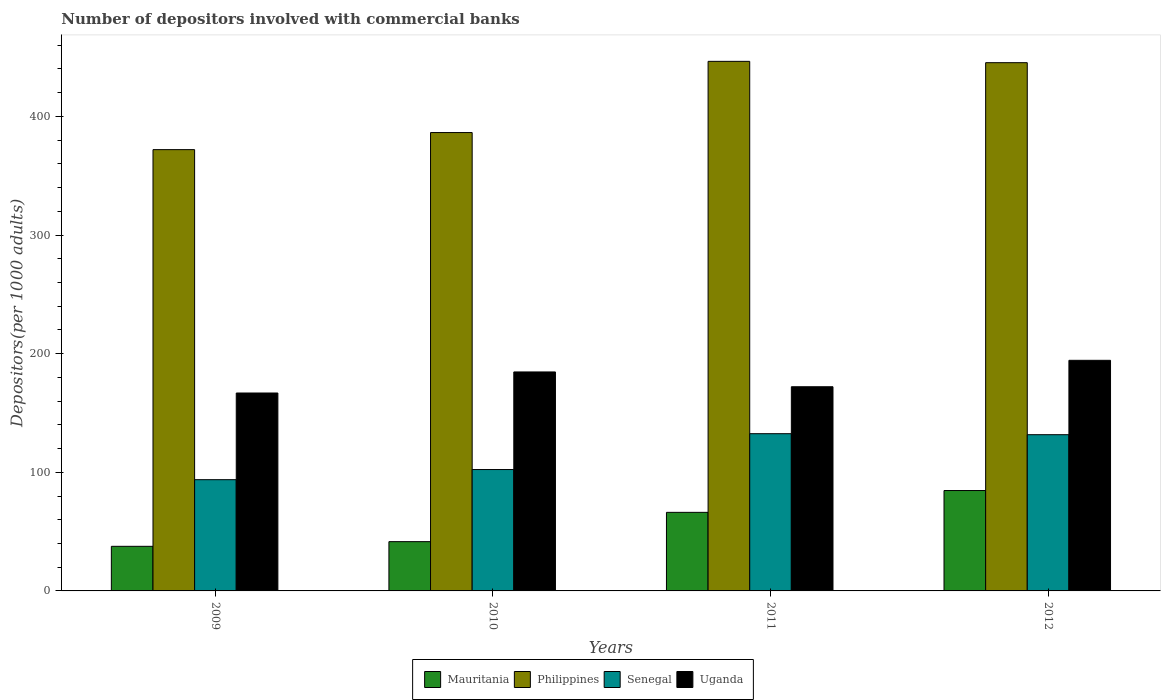How many different coloured bars are there?
Keep it short and to the point. 4. How many bars are there on the 3rd tick from the left?
Ensure brevity in your answer.  4. What is the number of depositors involved with commercial banks in Mauritania in 2009?
Your answer should be very brief. 37.6. Across all years, what is the maximum number of depositors involved with commercial banks in Philippines?
Keep it short and to the point. 446.4. Across all years, what is the minimum number of depositors involved with commercial banks in Philippines?
Give a very brief answer. 371.98. In which year was the number of depositors involved with commercial banks in Philippines minimum?
Provide a short and direct response. 2009. What is the total number of depositors involved with commercial banks in Mauritania in the graph?
Provide a succinct answer. 229.98. What is the difference between the number of depositors involved with commercial banks in Senegal in 2009 and that in 2012?
Ensure brevity in your answer.  -37.92. What is the difference between the number of depositors involved with commercial banks in Uganda in 2011 and the number of depositors involved with commercial banks in Mauritania in 2010?
Make the answer very short. 130.57. What is the average number of depositors involved with commercial banks in Mauritania per year?
Ensure brevity in your answer.  57.5. In the year 2010, what is the difference between the number of depositors involved with commercial banks in Uganda and number of depositors involved with commercial banks in Philippines?
Your answer should be compact. -201.8. In how many years, is the number of depositors involved with commercial banks in Philippines greater than 260?
Offer a very short reply. 4. What is the ratio of the number of depositors involved with commercial banks in Senegal in 2009 to that in 2011?
Offer a very short reply. 0.71. Is the difference between the number of depositors involved with commercial banks in Uganda in 2009 and 2011 greater than the difference between the number of depositors involved with commercial banks in Philippines in 2009 and 2011?
Offer a terse response. Yes. What is the difference between the highest and the second highest number of depositors involved with commercial banks in Philippines?
Offer a very short reply. 1.12. What is the difference between the highest and the lowest number of depositors involved with commercial banks in Mauritania?
Your answer should be very brief. 47.01. In how many years, is the number of depositors involved with commercial banks in Senegal greater than the average number of depositors involved with commercial banks in Senegal taken over all years?
Offer a terse response. 2. What does the 1st bar from the left in 2012 represents?
Your response must be concise. Mauritania. Are all the bars in the graph horizontal?
Provide a short and direct response. No. What is the difference between two consecutive major ticks on the Y-axis?
Your answer should be compact. 100. Does the graph contain any zero values?
Give a very brief answer. No. Does the graph contain grids?
Make the answer very short. No. Where does the legend appear in the graph?
Your answer should be compact. Bottom center. How many legend labels are there?
Offer a very short reply. 4. What is the title of the graph?
Your response must be concise. Number of depositors involved with commercial banks. What is the label or title of the Y-axis?
Offer a terse response. Depositors(per 1000 adults). What is the Depositors(per 1000 adults) of Mauritania in 2009?
Keep it short and to the point. 37.6. What is the Depositors(per 1000 adults) in Philippines in 2009?
Provide a short and direct response. 371.98. What is the Depositors(per 1000 adults) in Senegal in 2009?
Provide a short and direct response. 93.77. What is the Depositors(per 1000 adults) of Uganda in 2009?
Provide a succinct answer. 166.83. What is the Depositors(per 1000 adults) of Mauritania in 2010?
Keep it short and to the point. 41.54. What is the Depositors(per 1000 adults) in Philippines in 2010?
Provide a short and direct response. 386.38. What is the Depositors(per 1000 adults) in Senegal in 2010?
Make the answer very short. 102.32. What is the Depositors(per 1000 adults) of Uganda in 2010?
Your answer should be compact. 184.58. What is the Depositors(per 1000 adults) in Mauritania in 2011?
Your answer should be compact. 66.23. What is the Depositors(per 1000 adults) in Philippines in 2011?
Provide a short and direct response. 446.4. What is the Depositors(per 1000 adults) in Senegal in 2011?
Provide a succinct answer. 132.54. What is the Depositors(per 1000 adults) in Uganda in 2011?
Offer a very short reply. 172.11. What is the Depositors(per 1000 adults) of Mauritania in 2012?
Your answer should be compact. 84.61. What is the Depositors(per 1000 adults) of Philippines in 2012?
Make the answer very short. 445.28. What is the Depositors(per 1000 adults) of Senegal in 2012?
Your response must be concise. 131.69. What is the Depositors(per 1000 adults) of Uganda in 2012?
Make the answer very short. 194.39. Across all years, what is the maximum Depositors(per 1000 adults) in Mauritania?
Offer a very short reply. 84.61. Across all years, what is the maximum Depositors(per 1000 adults) of Philippines?
Offer a very short reply. 446.4. Across all years, what is the maximum Depositors(per 1000 adults) of Senegal?
Keep it short and to the point. 132.54. Across all years, what is the maximum Depositors(per 1000 adults) of Uganda?
Your response must be concise. 194.39. Across all years, what is the minimum Depositors(per 1000 adults) of Mauritania?
Ensure brevity in your answer.  37.6. Across all years, what is the minimum Depositors(per 1000 adults) of Philippines?
Offer a terse response. 371.98. Across all years, what is the minimum Depositors(per 1000 adults) of Senegal?
Your answer should be very brief. 93.77. Across all years, what is the minimum Depositors(per 1000 adults) of Uganda?
Give a very brief answer. 166.83. What is the total Depositors(per 1000 adults) of Mauritania in the graph?
Give a very brief answer. 229.98. What is the total Depositors(per 1000 adults) in Philippines in the graph?
Your answer should be very brief. 1650.04. What is the total Depositors(per 1000 adults) in Senegal in the graph?
Provide a succinct answer. 460.32. What is the total Depositors(per 1000 adults) in Uganda in the graph?
Ensure brevity in your answer.  717.9. What is the difference between the Depositors(per 1000 adults) of Mauritania in 2009 and that in 2010?
Give a very brief answer. -3.93. What is the difference between the Depositors(per 1000 adults) of Philippines in 2009 and that in 2010?
Keep it short and to the point. -14.4. What is the difference between the Depositors(per 1000 adults) of Senegal in 2009 and that in 2010?
Your response must be concise. -8.56. What is the difference between the Depositors(per 1000 adults) in Uganda in 2009 and that in 2010?
Make the answer very short. -17.75. What is the difference between the Depositors(per 1000 adults) in Mauritania in 2009 and that in 2011?
Provide a short and direct response. -28.63. What is the difference between the Depositors(per 1000 adults) of Philippines in 2009 and that in 2011?
Offer a very short reply. -74.42. What is the difference between the Depositors(per 1000 adults) of Senegal in 2009 and that in 2011?
Your response must be concise. -38.77. What is the difference between the Depositors(per 1000 adults) in Uganda in 2009 and that in 2011?
Ensure brevity in your answer.  -5.28. What is the difference between the Depositors(per 1000 adults) in Mauritania in 2009 and that in 2012?
Make the answer very short. -47.01. What is the difference between the Depositors(per 1000 adults) of Philippines in 2009 and that in 2012?
Your answer should be compact. -73.3. What is the difference between the Depositors(per 1000 adults) of Senegal in 2009 and that in 2012?
Offer a terse response. -37.92. What is the difference between the Depositors(per 1000 adults) in Uganda in 2009 and that in 2012?
Provide a succinct answer. -27.56. What is the difference between the Depositors(per 1000 adults) of Mauritania in 2010 and that in 2011?
Your answer should be compact. -24.69. What is the difference between the Depositors(per 1000 adults) in Philippines in 2010 and that in 2011?
Keep it short and to the point. -60.02. What is the difference between the Depositors(per 1000 adults) in Senegal in 2010 and that in 2011?
Provide a succinct answer. -30.21. What is the difference between the Depositors(per 1000 adults) of Uganda in 2010 and that in 2011?
Offer a very short reply. 12.47. What is the difference between the Depositors(per 1000 adults) in Mauritania in 2010 and that in 2012?
Give a very brief answer. -43.07. What is the difference between the Depositors(per 1000 adults) in Philippines in 2010 and that in 2012?
Your answer should be compact. -58.9. What is the difference between the Depositors(per 1000 adults) in Senegal in 2010 and that in 2012?
Offer a very short reply. -29.37. What is the difference between the Depositors(per 1000 adults) in Uganda in 2010 and that in 2012?
Offer a terse response. -9.81. What is the difference between the Depositors(per 1000 adults) of Mauritania in 2011 and that in 2012?
Offer a terse response. -18.38. What is the difference between the Depositors(per 1000 adults) in Philippines in 2011 and that in 2012?
Give a very brief answer. 1.12. What is the difference between the Depositors(per 1000 adults) in Senegal in 2011 and that in 2012?
Keep it short and to the point. 0.84. What is the difference between the Depositors(per 1000 adults) in Uganda in 2011 and that in 2012?
Make the answer very short. -22.28. What is the difference between the Depositors(per 1000 adults) of Mauritania in 2009 and the Depositors(per 1000 adults) of Philippines in 2010?
Offer a very short reply. -348.78. What is the difference between the Depositors(per 1000 adults) in Mauritania in 2009 and the Depositors(per 1000 adults) in Senegal in 2010?
Your answer should be very brief. -64.72. What is the difference between the Depositors(per 1000 adults) of Mauritania in 2009 and the Depositors(per 1000 adults) of Uganda in 2010?
Make the answer very short. -146.98. What is the difference between the Depositors(per 1000 adults) of Philippines in 2009 and the Depositors(per 1000 adults) of Senegal in 2010?
Make the answer very short. 269.65. What is the difference between the Depositors(per 1000 adults) of Philippines in 2009 and the Depositors(per 1000 adults) of Uganda in 2010?
Ensure brevity in your answer.  187.4. What is the difference between the Depositors(per 1000 adults) in Senegal in 2009 and the Depositors(per 1000 adults) in Uganda in 2010?
Your answer should be compact. -90.81. What is the difference between the Depositors(per 1000 adults) in Mauritania in 2009 and the Depositors(per 1000 adults) in Philippines in 2011?
Provide a succinct answer. -408.8. What is the difference between the Depositors(per 1000 adults) in Mauritania in 2009 and the Depositors(per 1000 adults) in Senegal in 2011?
Make the answer very short. -94.93. What is the difference between the Depositors(per 1000 adults) in Mauritania in 2009 and the Depositors(per 1000 adults) in Uganda in 2011?
Ensure brevity in your answer.  -134.5. What is the difference between the Depositors(per 1000 adults) of Philippines in 2009 and the Depositors(per 1000 adults) of Senegal in 2011?
Give a very brief answer. 239.44. What is the difference between the Depositors(per 1000 adults) in Philippines in 2009 and the Depositors(per 1000 adults) in Uganda in 2011?
Your answer should be compact. 199.87. What is the difference between the Depositors(per 1000 adults) of Senegal in 2009 and the Depositors(per 1000 adults) of Uganda in 2011?
Your answer should be compact. -78.34. What is the difference between the Depositors(per 1000 adults) of Mauritania in 2009 and the Depositors(per 1000 adults) of Philippines in 2012?
Offer a terse response. -407.68. What is the difference between the Depositors(per 1000 adults) of Mauritania in 2009 and the Depositors(per 1000 adults) of Senegal in 2012?
Keep it short and to the point. -94.09. What is the difference between the Depositors(per 1000 adults) of Mauritania in 2009 and the Depositors(per 1000 adults) of Uganda in 2012?
Make the answer very short. -156.79. What is the difference between the Depositors(per 1000 adults) in Philippines in 2009 and the Depositors(per 1000 adults) in Senegal in 2012?
Ensure brevity in your answer.  240.29. What is the difference between the Depositors(per 1000 adults) of Philippines in 2009 and the Depositors(per 1000 adults) of Uganda in 2012?
Offer a terse response. 177.59. What is the difference between the Depositors(per 1000 adults) in Senegal in 2009 and the Depositors(per 1000 adults) in Uganda in 2012?
Your response must be concise. -100.62. What is the difference between the Depositors(per 1000 adults) of Mauritania in 2010 and the Depositors(per 1000 adults) of Philippines in 2011?
Offer a very short reply. -404.86. What is the difference between the Depositors(per 1000 adults) in Mauritania in 2010 and the Depositors(per 1000 adults) in Senegal in 2011?
Provide a short and direct response. -91. What is the difference between the Depositors(per 1000 adults) of Mauritania in 2010 and the Depositors(per 1000 adults) of Uganda in 2011?
Offer a very short reply. -130.57. What is the difference between the Depositors(per 1000 adults) of Philippines in 2010 and the Depositors(per 1000 adults) of Senegal in 2011?
Make the answer very short. 253.85. What is the difference between the Depositors(per 1000 adults) in Philippines in 2010 and the Depositors(per 1000 adults) in Uganda in 2011?
Ensure brevity in your answer.  214.28. What is the difference between the Depositors(per 1000 adults) in Senegal in 2010 and the Depositors(per 1000 adults) in Uganda in 2011?
Provide a short and direct response. -69.78. What is the difference between the Depositors(per 1000 adults) of Mauritania in 2010 and the Depositors(per 1000 adults) of Philippines in 2012?
Provide a succinct answer. -403.74. What is the difference between the Depositors(per 1000 adults) in Mauritania in 2010 and the Depositors(per 1000 adults) in Senegal in 2012?
Ensure brevity in your answer.  -90.16. What is the difference between the Depositors(per 1000 adults) of Mauritania in 2010 and the Depositors(per 1000 adults) of Uganda in 2012?
Offer a terse response. -152.85. What is the difference between the Depositors(per 1000 adults) of Philippines in 2010 and the Depositors(per 1000 adults) of Senegal in 2012?
Keep it short and to the point. 254.69. What is the difference between the Depositors(per 1000 adults) of Philippines in 2010 and the Depositors(per 1000 adults) of Uganda in 2012?
Your response must be concise. 191.99. What is the difference between the Depositors(per 1000 adults) in Senegal in 2010 and the Depositors(per 1000 adults) in Uganda in 2012?
Offer a terse response. -92.06. What is the difference between the Depositors(per 1000 adults) in Mauritania in 2011 and the Depositors(per 1000 adults) in Philippines in 2012?
Provide a succinct answer. -379.05. What is the difference between the Depositors(per 1000 adults) of Mauritania in 2011 and the Depositors(per 1000 adults) of Senegal in 2012?
Make the answer very short. -65.46. What is the difference between the Depositors(per 1000 adults) in Mauritania in 2011 and the Depositors(per 1000 adults) in Uganda in 2012?
Your answer should be very brief. -128.16. What is the difference between the Depositors(per 1000 adults) of Philippines in 2011 and the Depositors(per 1000 adults) of Senegal in 2012?
Ensure brevity in your answer.  314.71. What is the difference between the Depositors(per 1000 adults) in Philippines in 2011 and the Depositors(per 1000 adults) in Uganda in 2012?
Offer a very short reply. 252.01. What is the difference between the Depositors(per 1000 adults) in Senegal in 2011 and the Depositors(per 1000 adults) in Uganda in 2012?
Ensure brevity in your answer.  -61.85. What is the average Depositors(per 1000 adults) of Mauritania per year?
Give a very brief answer. 57.5. What is the average Depositors(per 1000 adults) in Philippines per year?
Give a very brief answer. 412.51. What is the average Depositors(per 1000 adults) of Senegal per year?
Provide a short and direct response. 115.08. What is the average Depositors(per 1000 adults) of Uganda per year?
Give a very brief answer. 179.48. In the year 2009, what is the difference between the Depositors(per 1000 adults) in Mauritania and Depositors(per 1000 adults) in Philippines?
Offer a terse response. -334.38. In the year 2009, what is the difference between the Depositors(per 1000 adults) in Mauritania and Depositors(per 1000 adults) in Senegal?
Your response must be concise. -56.17. In the year 2009, what is the difference between the Depositors(per 1000 adults) in Mauritania and Depositors(per 1000 adults) in Uganda?
Provide a short and direct response. -129.23. In the year 2009, what is the difference between the Depositors(per 1000 adults) of Philippines and Depositors(per 1000 adults) of Senegal?
Give a very brief answer. 278.21. In the year 2009, what is the difference between the Depositors(per 1000 adults) of Philippines and Depositors(per 1000 adults) of Uganda?
Ensure brevity in your answer.  205.15. In the year 2009, what is the difference between the Depositors(per 1000 adults) of Senegal and Depositors(per 1000 adults) of Uganda?
Your response must be concise. -73.06. In the year 2010, what is the difference between the Depositors(per 1000 adults) in Mauritania and Depositors(per 1000 adults) in Philippines?
Provide a short and direct response. -344.85. In the year 2010, what is the difference between the Depositors(per 1000 adults) of Mauritania and Depositors(per 1000 adults) of Senegal?
Your response must be concise. -60.79. In the year 2010, what is the difference between the Depositors(per 1000 adults) in Mauritania and Depositors(per 1000 adults) in Uganda?
Offer a terse response. -143.04. In the year 2010, what is the difference between the Depositors(per 1000 adults) of Philippines and Depositors(per 1000 adults) of Senegal?
Your answer should be very brief. 284.06. In the year 2010, what is the difference between the Depositors(per 1000 adults) in Philippines and Depositors(per 1000 adults) in Uganda?
Provide a short and direct response. 201.8. In the year 2010, what is the difference between the Depositors(per 1000 adults) of Senegal and Depositors(per 1000 adults) of Uganda?
Your response must be concise. -82.25. In the year 2011, what is the difference between the Depositors(per 1000 adults) in Mauritania and Depositors(per 1000 adults) in Philippines?
Give a very brief answer. -380.17. In the year 2011, what is the difference between the Depositors(per 1000 adults) in Mauritania and Depositors(per 1000 adults) in Senegal?
Your answer should be compact. -66.31. In the year 2011, what is the difference between the Depositors(per 1000 adults) in Mauritania and Depositors(per 1000 adults) in Uganda?
Ensure brevity in your answer.  -105.88. In the year 2011, what is the difference between the Depositors(per 1000 adults) of Philippines and Depositors(per 1000 adults) of Senegal?
Keep it short and to the point. 313.86. In the year 2011, what is the difference between the Depositors(per 1000 adults) of Philippines and Depositors(per 1000 adults) of Uganda?
Offer a terse response. 274.29. In the year 2011, what is the difference between the Depositors(per 1000 adults) of Senegal and Depositors(per 1000 adults) of Uganda?
Make the answer very short. -39.57. In the year 2012, what is the difference between the Depositors(per 1000 adults) of Mauritania and Depositors(per 1000 adults) of Philippines?
Provide a succinct answer. -360.67. In the year 2012, what is the difference between the Depositors(per 1000 adults) in Mauritania and Depositors(per 1000 adults) in Senegal?
Ensure brevity in your answer.  -47.08. In the year 2012, what is the difference between the Depositors(per 1000 adults) of Mauritania and Depositors(per 1000 adults) of Uganda?
Your answer should be very brief. -109.78. In the year 2012, what is the difference between the Depositors(per 1000 adults) of Philippines and Depositors(per 1000 adults) of Senegal?
Make the answer very short. 313.58. In the year 2012, what is the difference between the Depositors(per 1000 adults) of Philippines and Depositors(per 1000 adults) of Uganda?
Offer a very short reply. 250.89. In the year 2012, what is the difference between the Depositors(per 1000 adults) in Senegal and Depositors(per 1000 adults) in Uganda?
Give a very brief answer. -62.69. What is the ratio of the Depositors(per 1000 adults) in Mauritania in 2009 to that in 2010?
Offer a terse response. 0.91. What is the ratio of the Depositors(per 1000 adults) in Philippines in 2009 to that in 2010?
Provide a succinct answer. 0.96. What is the ratio of the Depositors(per 1000 adults) of Senegal in 2009 to that in 2010?
Make the answer very short. 0.92. What is the ratio of the Depositors(per 1000 adults) of Uganda in 2009 to that in 2010?
Offer a terse response. 0.9. What is the ratio of the Depositors(per 1000 adults) in Mauritania in 2009 to that in 2011?
Your response must be concise. 0.57. What is the ratio of the Depositors(per 1000 adults) of Philippines in 2009 to that in 2011?
Make the answer very short. 0.83. What is the ratio of the Depositors(per 1000 adults) of Senegal in 2009 to that in 2011?
Offer a terse response. 0.71. What is the ratio of the Depositors(per 1000 adults) in Uganda in 2009 to that in 2011?
Your answer should be compact. 0.97. What is the ratio of the Depositors(per 1000 adults) of Mauritania in 2009 to that in 2012?
Offer a very short reply. 0.44. What is the ratio of the Depositors(per 1000 adults) in Philippines in 2009 to that in 2012?
Provide a short and direct response. 0.84. What is the ratio of the Depositors(per 1000 adults) in Senegal in 2009 to that in 2012?
Your answer should be very brief. 0.71. What is the ratio of the Depositors(per 1000 adults) in Uganda in 2009 to that in 2012?
Provide a succinct answer. 0.86. What is the ratio of the Depositors(per 1000 adults) of Mauritania in 2010 to that in 2011?
Offer a very short reply. 0.63. What is the ratio of the Depositors(per 1000 adults) of Philippines in 2010 to that in 2011?
Make the answer very short. 0.87. What is the ratio of the Depositors(per 1000 adults) of Senegal in 2010 to that in 2011?
Keep it short and to the point. 0.77. What is the ratio of the Depositors(per 1000 adults) in Uganda in 2010 to that in 2011?
Give a very brief answer. 1.07. What is the ratio of the Depositors(per 1000 adults) of Mauritania in 2010 to that in 2012?
Your answer should be compact. 0.49. What is the ratio of the Depositors(per 1000 adults) of Philippines in 2010 to that in 2012?
Make the answer very short. 0.87. What is the ratio of the Depositors(per 1000 adults) of Senegal in 2010 to that in 2012?
Make the answer very short. 0.78. What is the ratio of the Depositors(per 1000 adults) in Uganda in 2010 to that in 2012?
Make the answer very short. 0.95. What is the ratio of the Depositors(per 1000 adults) of Mauritania in 2011 to that in 2012?
Ensure brevity in your answer.  0.78. What is the ratio of the Depositors(per 1000 adults) in Philippines in 2011 to that in 2012?
Give a very brief answer. 1. What is the ratio of the Depositors(per 1000 adults) in Senegal in 2011 to that in 2012?
Ensure brevity in your answer.  1.01. What is the ratio of the Depositors(per 1000 adults) of Uganda in 2011 to that in 2012?
Your answer should be very brief. 0.89. What is the difference between the highest and the second highest Depositors(per 1000 adults) in Mauritania?
Provide a succinct answer. 18.38. What is the difference between the highest and the second highest Depositors(per 1000 adults) of Philippines?
Your answer should be very brief. 1.12. What is the difference between the highest and the second highest Depositors(per 1000 adults) in Senegal?
Provide a succinct answer. 0.84. What is the difference between the highest and the second highest Depositors(per 1000 adults) in Uganda?
Offer a very short reply. 9.81. What is the difference between the highest and the lowest Depositors(per 1000 adults) in Mauritania?
Your response must be concise. 47.01. What is the difference between the highest and the lowest Depositors(per 1000 adults) in Philippines?
Offer a very short reply. 74.42. What is the difference between the highest and the lowest Depositors(per 1000 adults) in Senegal?
Keep it short and to the point. 38.77. What is the difference between the highest and the lowest Depositors(per 1000 adults) in Uganda?
Your answer should be very brief. 27.56. 